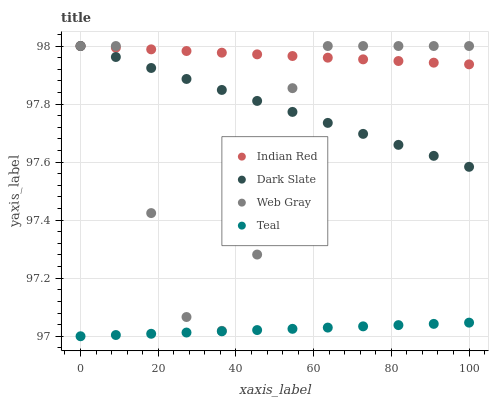Does Teal have the minimum area under the curve?
Answer yes or no. Yes. Does Indian Red have the maximum area under the curve?
Answer yes or no. Yes. Does Web Gray have the minimum area under the curve?
Answer yes or no. No. Does Web Gray have the maximum area under the curve?
Answer yes or no. No. Is Indian Red the smoothest?
Answer yes or no. Yes. Is Web Gray the roughest?
Answer yes or no. Yes. Is Teal the smoothest?
Answer yes or no. No. Is Teal the roughest?
Answer yes or no. No. Does Teal have the lowest value?
Answer yes or no. Yes. Does Web Gray have the lowest value?
Answer yes or no. No. Does Indian Red have the highest value?
Answer yes or no. Yes. Does Teal have the highest value?
Answer yes or no. No. Is Teal less than Indian Red?
Answer yes or no. Yes. Is Indian Red greater than Teal?
Answer yes or no. Yes. Does Indian Red intersect Dark Slate?
Answer yes or no. Yes. Is Indian Red less than Dark Slate?
Answer yes or no. No. Is Indian Red greater than Dark Slate?
Answer yes or no. No. Does Teal intersect Indian Red?
Answer yes or no. No. 